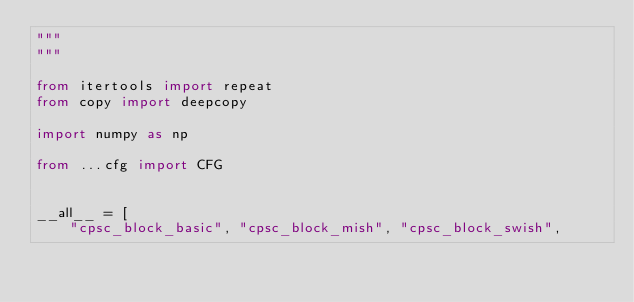<code> <loc_0><loc_0><loc_500><loc_500><_Python_>"""
"""

from itertools import repeat
from copy import deepcopy

import numpy as np

from ...cfg import CFG


__all__ = [
    "cpsc_block_basic", "cpsc_block_mish", "cpsc_block_swish",</code> 